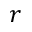<formula> <loc_0><loc_0><loc_500><loc_500>r</formula> 